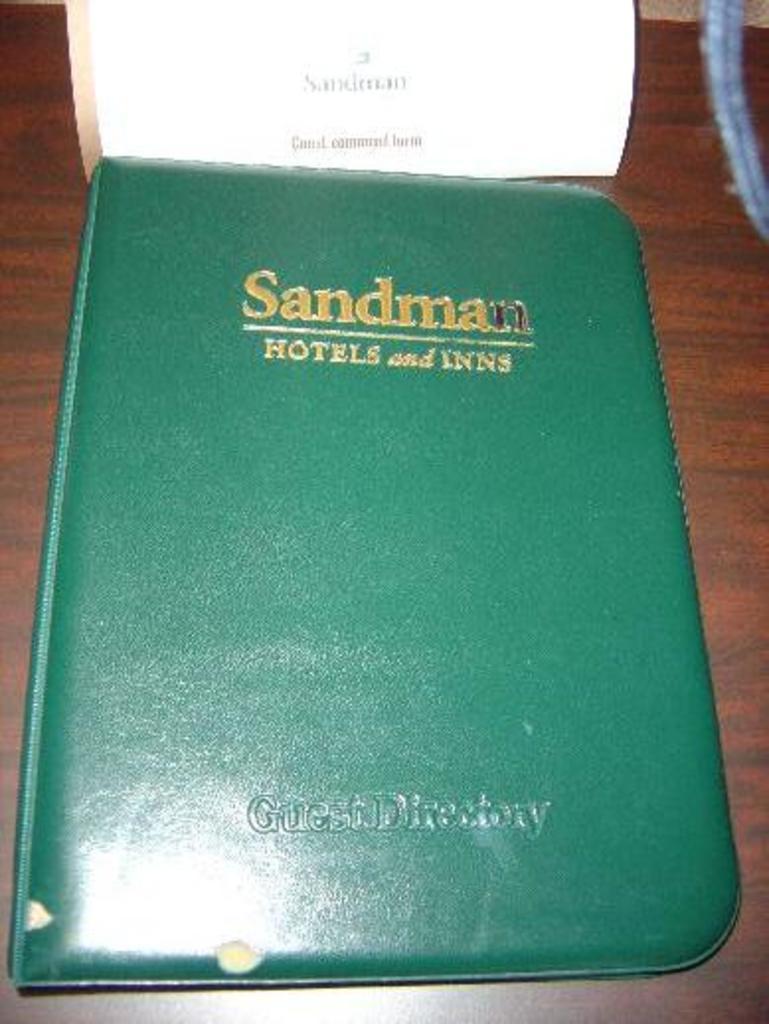What brand of hotels?
Provide a short and direct response. Sandman. 